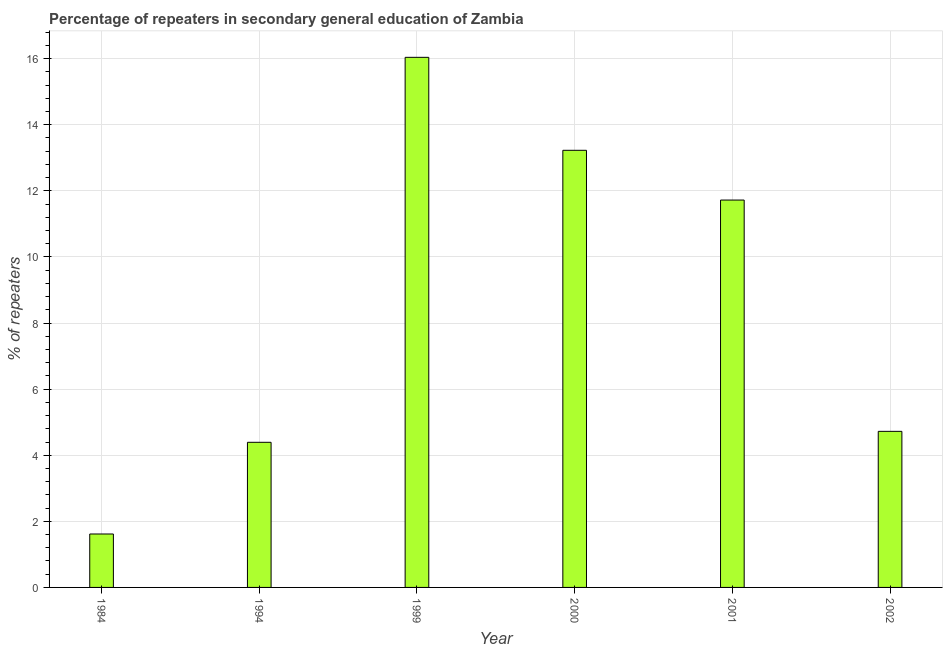Does the graph contain grids?
Your answer should be very brief. Yes. What is the title of the graph?
Your response must be concise. Percentage of repeaters in secondary general education of Zambia. What is the label or title of the Y-axis?
Keep it short and to the point. % of repeaters. What is the percentage of repeaters in 2002?
Provide a succinct answer. 4.72. Across all years, what is the maximum percentage of repeaters?
Offer a very short reply. 16.04. Across all years, what is the minimum percentage of repeaters?
Make the answer very short. 1.62. In which year was the percentage of repeaters maximum?
Make the answer very short. 1999. What is the sum of the percentage of repeaters?
Provide a succinct answer. 51.72. What is the difference between the percentage of repeaters in 1984 and 2001?
Your answer should be compact. -10.11. What is the average percentage of repeaters per year?
Your response must be concise. 8.62. What is the median percentage of repeaters?
Ensure brevity in your answer.  8.22. In how many years, is the percentage of repeaters greater than 11.6 %?
Make the answer very short. 3. Do a majority of the years between 2002 and 2001 (inclusive) have percentage of repeaters greater than 14.8 %?
Provide a short and direct response. No. What is the ratio of the percentage of repeaters in 1984 to that in 1994?
Give a very brief answer. 0.37. What is the difference between the highest and the second highest percentage of repeaters?
Ensure brevity in your answer.  2.81. Is the sum of the percentage of repeaters in 1999 and 2000 greater than the maximum percentage of repeaters across all years?
Offer a terse response. Yes. What is the difference between the highest and the lowest percentage of repeaters?
Ensure brevity in your answer.  14.42. How many bars are there?
Your answer should be compact. 6. Are all the bars in the graph horizontal?
Your response must be concise. No. How many years are there in the graph?
Provide a short and direct response. 6. What is the % of repeaters of 1984?
Provide a succinct answer. 1.62. What is the % of repeaters of 1994?
Give a very brief answer. 4.39. What is the % of repeaters of 1999?
Ensure brevity in your answer.  16.04. What is the % of repeaters in 2000?
Your answer should be very brief. 13.23. What is the % of repeaters in 2001?
Your answer should be very brief. 11.72. What is the % of repeaters in 2002?
Provide a short and direct response. 4.72. What is the difference between the % of repeaters in 1984 and 1994?
Provide a short and direct response. -2.77. What is the difference between the % of repeaters in 1984 and 1999?
Make the answer very short. -14.42. What is the difference between the % of repeaters in 1984 and 2000?
Offer a very short reply. -11.61. What is the difference between the % of repeaters in 1984 and 2001?
Provide a succinct answer. -10.1. What is the difference between the % of repeaters in 1984 and 2002?
Your answer should be compact. -3.11. What is the difference between the % of repeaters in 1994 and 1999?
Offer a very short reply. -11.65. What is the difference between the % of repeaters in 1994 and 2000?
Make the answer very short. -8.84. What is the difference between the % of repeaters in 1994 and 2001?
Keep it short and to the point. -7.33. What is the difference between the % of repeaters in 1994 and 2002?
Make the answer very short. -0.33. What is the difference between the % of repeaters in 1999 and 2000?
Your answer should be very brief. 2.81. What is the difference between the % of repeaters in 1999 and 2001?
Make the answer very short. 4.32. What is the difference between the % of repeaters in 1999 and 2002?
Your response must be concise. 11.32. What is the difference between the % of repeaters in 2000 and 2001?
Keep it short and to the point. 1.51. What is the difference between the % of repeaters in 2000 and 2002?
Provide a short and direct response. 8.5. What is the difference between the % of repeaters in 2001 and 2002?
Your answer should be very brief. 7. What is the ratio of the % of repeaters in 1984 to that in 1994?
Give a very brief answer. 0.37. What is the ratio of the % of repeaters in 1984 to that in 1999?
Your answer should be very brief. 0.1. What is the ratio of the % of repeaters in 1984 to that in 2000?
Give a very brief answer. 0.12. What is the ratio of the % of repeaters in 1984 to that in 2001?
Your answer should be very brief. 0.14. What is the ratio of the % of repeaters in 1984 to that in 2002?
Keep it short and to the point. 0.34. What is the ratio of the % of repeaters in 1994 to that in 1999?
Provide a short and direct response. 0.27. What is the ratio of the % of repeaters in 1994 to that in 2000?
Provide a succinct answer. 0.33. What is the ratio of the % of repeaters in 1994 to that in 2001?
Your answer should be compact. 0.38. What is the ratio of the % of repeaters in 1999 to that in 2000?
Your answer should be compact. 1.21. What is the ratio of the % of repeaters in 1999 to that in 2001?
Provide a succinct answer. 1.37. What is the ratio of the % of repeaters in 1999 to that in 2002?
Your answer should be very brief. 3.4. What is the ratio of the % of repeaters in 2000 to that in 2001?
Offer a terse response. 1.13. What is the ratio of the % of repeaters in 2000 to that in 2002?
Your response must be concise. 2.8. What is the ratio of the % of repeaters in 2001 to that in 2002?
Provide a succinct answer. 2.48. 